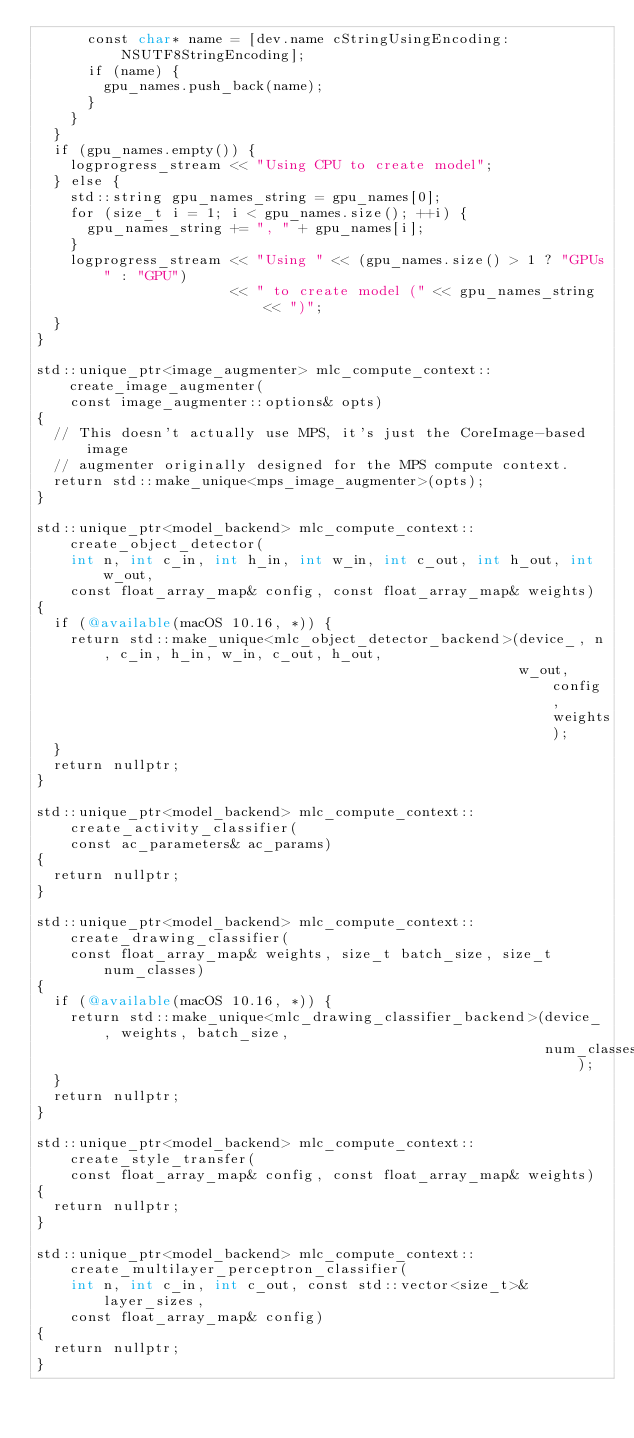<code> <loc_0><loc_0><loc_500><loc_500><_ObjectiveC_>      const char* name = [dev.name cStringUsingEncoding:NSUTF8StringEncoding];
      if (name) {
        gpu_names.push_back(name);
      }
    }
  }
  if (gpu_names.empty()) {
    logprogress_stream << "Using CPU to create model";
  } else {
    std::string gpu_names_string = gpu_names[0];
    for (size_t i = 1; i < gpu_names.size(); ++i) {
      gpu_names_string += ", " + gpu_names[i];
    }
    logprogress_stream << "Using " << (gpu_names.size() > 1 ? "GPUs" : "GPU")
                       << " to create model (" << gpu_names_string << ")";
  }
}

std::unique_ptr<image_augmenter> mlc_compute_context::create_image_augmenter(
    const image_augmenter::options& opts)
{
  // This doesn't actually use MPS, it's just the CoreImage-based image
  // augmenter originally designed for the MPS compute context.
  return std::make_unique<mps_image_augmenter>(opts);
}

std::unique_ptr<model_backend> mlc_compute_context::create_object_detector(
    int n, int c_in, int h_in, int w_in, int c_out, int h_out, int w_out,
    const float_array_map& config, const float_array_map& weights)
{
  if (@available(macOS 10.16, *)) {
    return std::make_unique<mlc_object_detector_backend>(device_, n, c_in, h_in, w_in, c_out, h_out,
                                                         w_out, config, weights);
  }
  return nullptr;
}

std::unique_ptr<model_backend> mlc_compute_context::create_activity_classifier(
    const ac_parameters& ac_params)
{
  return nullptr;
}

std::unique_ptr<model_backend> mlc_compute_context::create_drawing_classifier(
    const float_array_map& weights, size_t batch_size, size_t num_classes)
{
  if (@available(macOS 10.16, *)) {
    return std::make_unique<mlc_drawing_classifier_backend>(device_, weights, batch_size,
                                                            num_classes);
  }
  return nullptr;
}

std::unique_ptr<model_backend> mlc_compute_context::create_style_transfer(
    const float_array_map& config, const float_array_map& weights)
{
  return nullptr;
}

std::unique_ptr<model_backend> mlc_compute_context::create_multilayer_perceptron_classifier(
    int n, int c_in, int c_out, const std::vector<size_t>& layer_sizes,
    const float_array_map& config)
{
  return nullptr;
}
</code> 